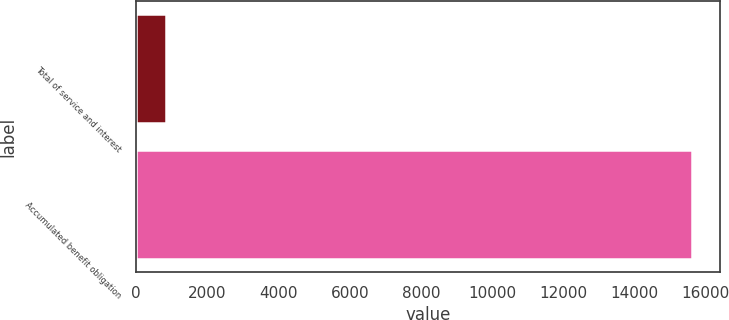<chart> <loc_0><loc_0><loc_500><loc_500><bar_chart><fcel>Total of service and interest<fcel>Accumulated benefit obligation<nl><fcel>824<fcel>15616<nl></chart> 